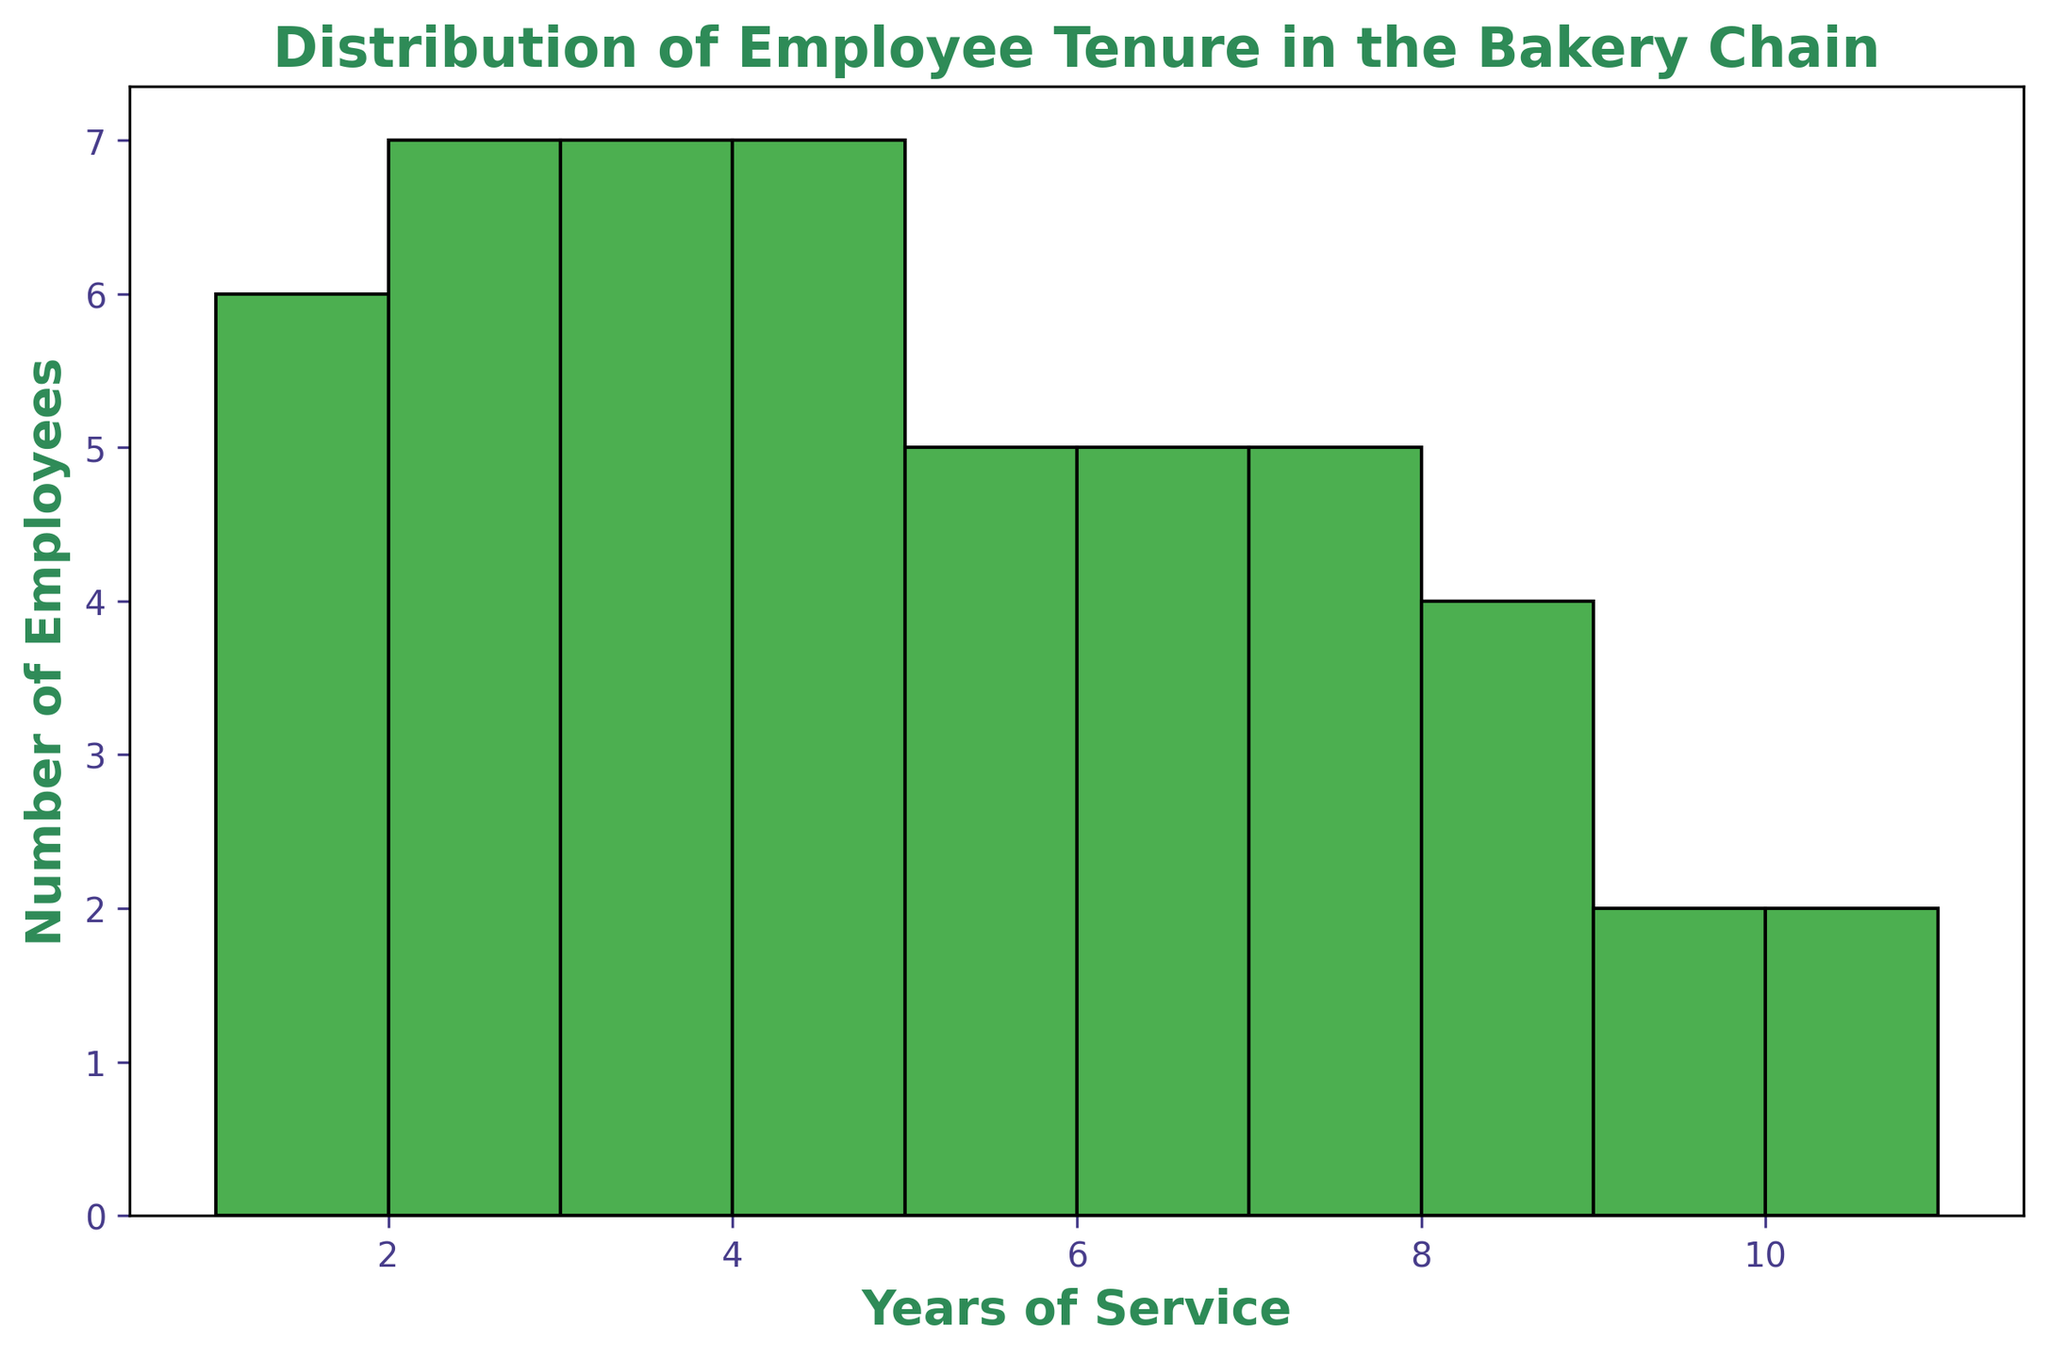What is the most common tenure among employees? To find the most common tenure, look for the bar with the highest height in the histogram. This represents the tenure with the largest number of employees. The bar corresponding to 3 years of service is the tallest.
Answer: 3 years How many employees have 6 or more years of service? Count the bars from 6 years upwards to 10 years. The heights of these bars represent the number of employees. There are 5 bars corresponding to 6, 7, 8, 9, and 10 years of service. Sum the heights: 5 (6 years) + 6 (7 years) + 4 (8 years) + 2 (9 years) + 2 (10 years) = 19 employees.
Answer: 19 employees Do more employees have 1 year of service or 4 years of service? Compare the heights of the bars corresponding to 1 year and 4 years of service. The bar for 1 year has a height of 6, and the bar for 4 years has a height of 6. So, they are equal.
Answer: Equal What is the sum of employees with 2 and 5 years of service combined? Add the heights of the bars corresponding to 2 years and 5 years of service. The height for 2 years is 7, and the height for 5 years is 6. So, 7 + 6 = 13 employees.
Answer: 13 employees Which tenure has more employees: 7 or 8 years of service? Compare the heights of the bars corresponding to 7 and 8 years of service. The height for 7 years is 6, and the height for 8 years is 4. Therefore, 7 years of service has more employees.
Answer: 7 years How many employees have between 1 and 3 years of service inclusive? Sum the heights of the bars corresponding to 1, 2, and 3 years of service. The heights are 6 (1 year) + 7 (2 years) + 8 (3 years). Therefore, 6 + 7 + 8 = 21 employees.
Answer: 21 employees Is the number of employees with exactly 3 years of service greater than those with exactly 6 years of service? Compare the heights of the bars corresponding to 3 years and 6 years of service. The height for 3 years is 8, and the height for 6 years is 5. Therefore, there are more employees with 3 years of service.
Answer: Yes 